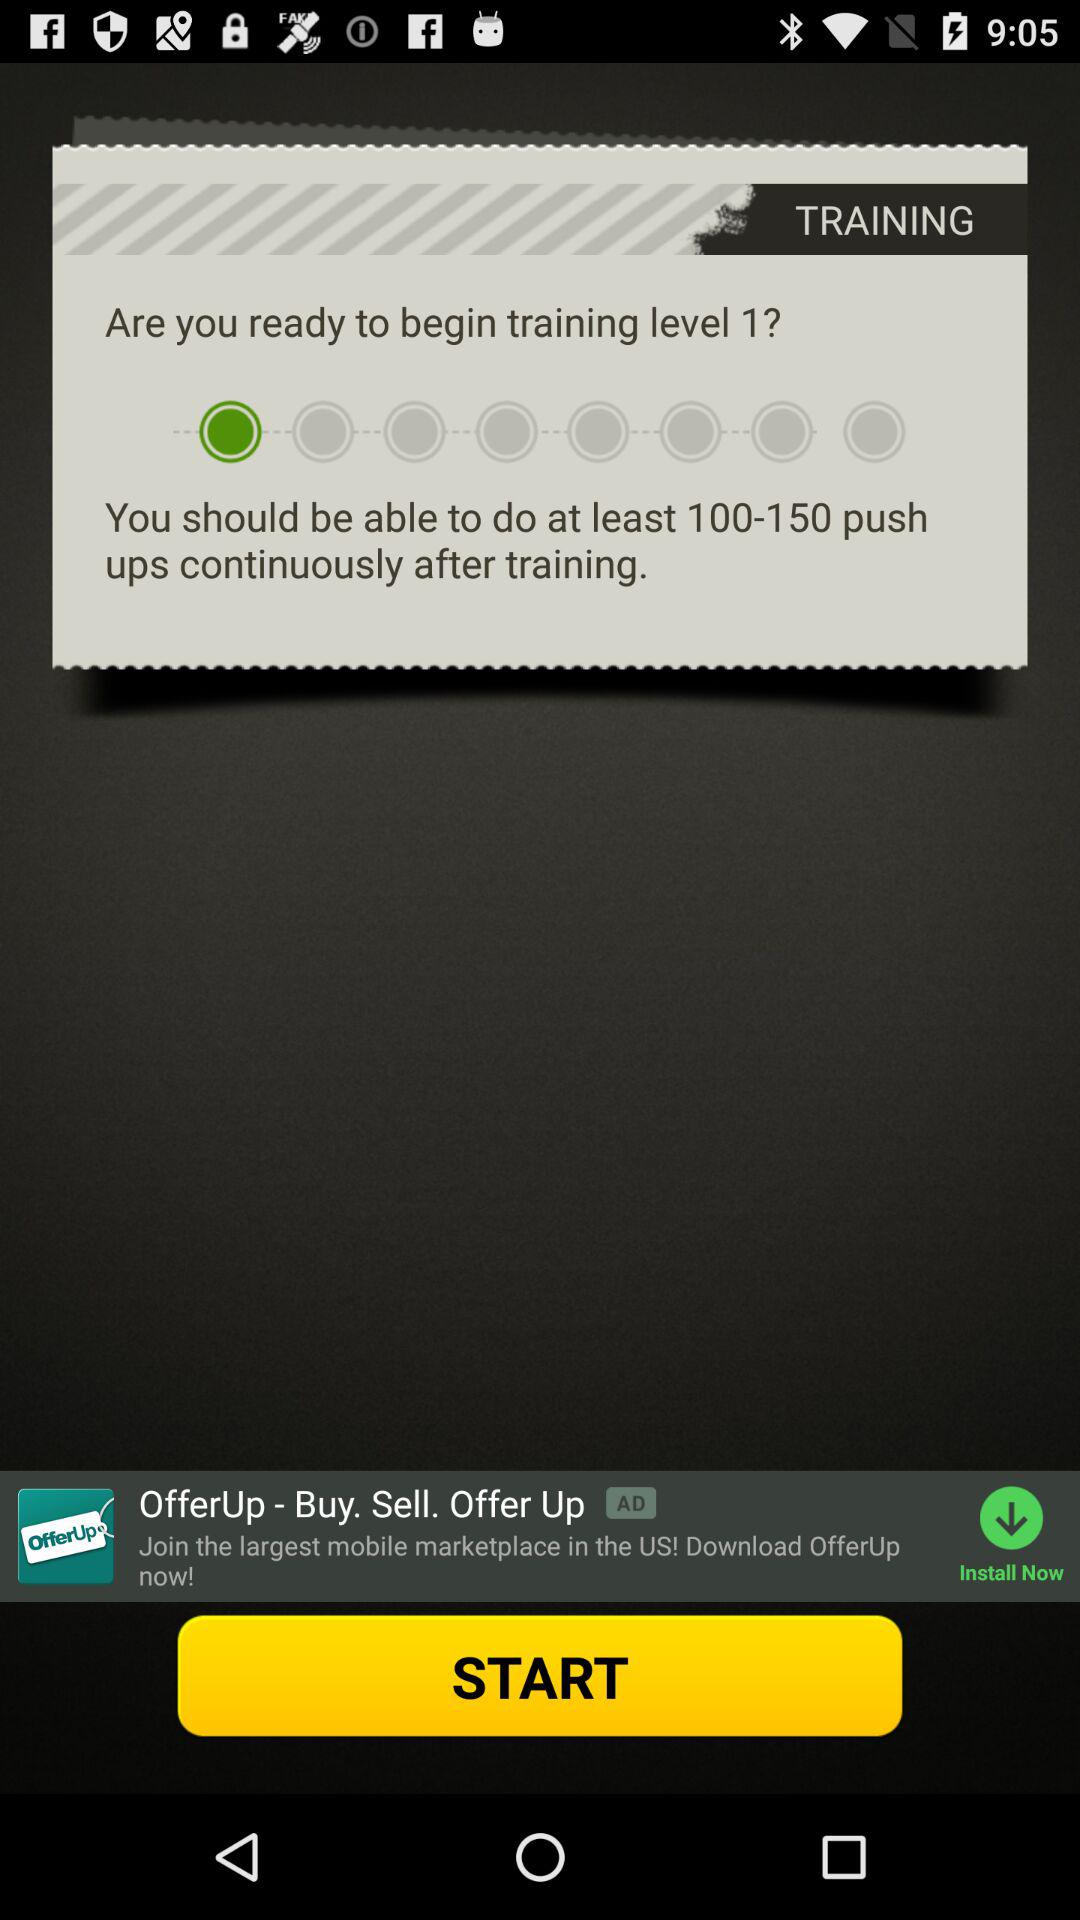How many push-ups do I have to do continuously after training? You have to do at least 100 to 150 push-ups continuously after training. 